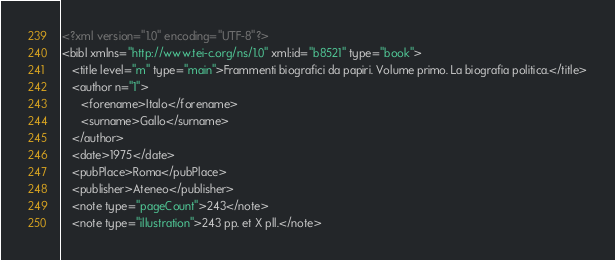<code> <loc_0><loc_0><loc_500><loc_500><_XML_><?xml version="1.0" encoding="UTF-8"?>
<bibl xmlns="http://www.tei-c.org/ns/1.0" xml:id="b8521" type="book">
   <title level="m" type="main">Frammenti biografici da papiri. Volume primo. La biografia politica.</title>
   <author n="1">
      <forename>Italo</forename>
      <surname>Gallo</surname>
   </author>
   <date>1975</date>
   <pubPlace>Roma</pubPlace>
   <publisher>Ateneo</publisher>
   <note type="pageCount">243</note>
   <note type="illustration">243 pp. et X pll.</note></code> 